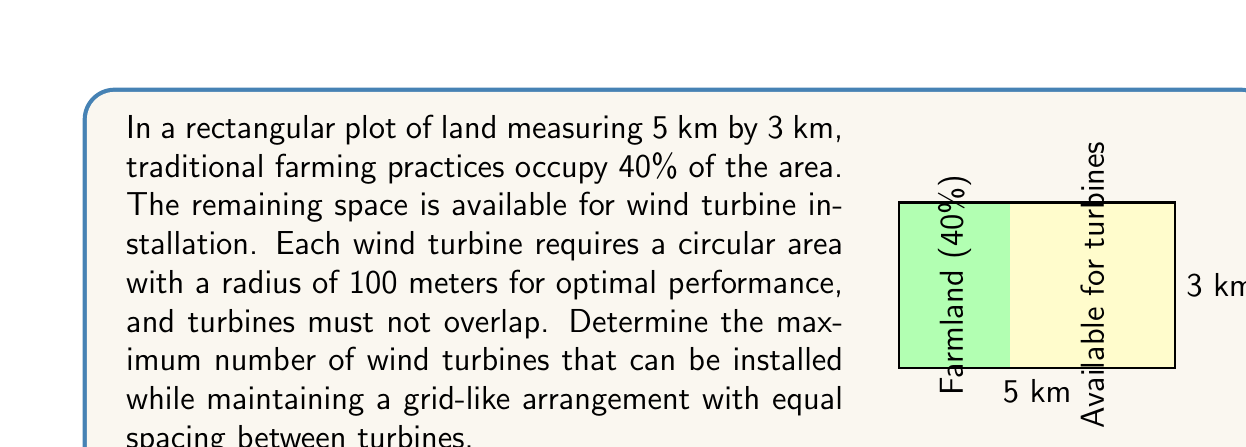Give your solution to this math problem. Let's approach this step-by-step:

1) First, calculate the total area of the plot:
   $$ A_{total} = 5 \text{ km} \times 3 \text{ km} = 15 \text{ km}^2 $$

2) Calculate the area available for wind turbines:
   $$ A_{available} = 60\% \times 15 \text{ km}^2 = 9 \text{ km}^2 = 9,000,000 \text{ m}^2 $$

3) Each turbine requires a circular area with radius 100 m. The area per turbine is:
   $$ A_{turbine} = \pi r^2 = \pi (100 \text{ m})^2 = 31,415.93 \text{ m}^2 $$

4) To maintain a grid-like arrangement, we need to consider the square area that encompasses each circular turbine area. The side length of this square would be the diameter of the circular area:
   $$ s = 2r = 2 \times 100 \text{ m} = 200 \text{ m} $$

5) The area of the square per turbine:
   $$ A_{square} = s^2 = (200 \text{ m})^2 = 40,000 \text{ m}^2 $$

6) Number of turbines that can fit in the available area:
   $$ N = \frac{A_{available}}{A_{square}} = \frac{9,000,000 \text{ m}^2}{40,000 \text{ m}^2} = 225 $$

7) To ensure a grid-like arrangement, we need to find the largest perfect square number less than or equal to 225:
   $$ 15^2 = 225 $$

Therefore, the maximum number of wind turbines that can be installed in a grid-like arrangement is 225.
Answer: 225 turbines 